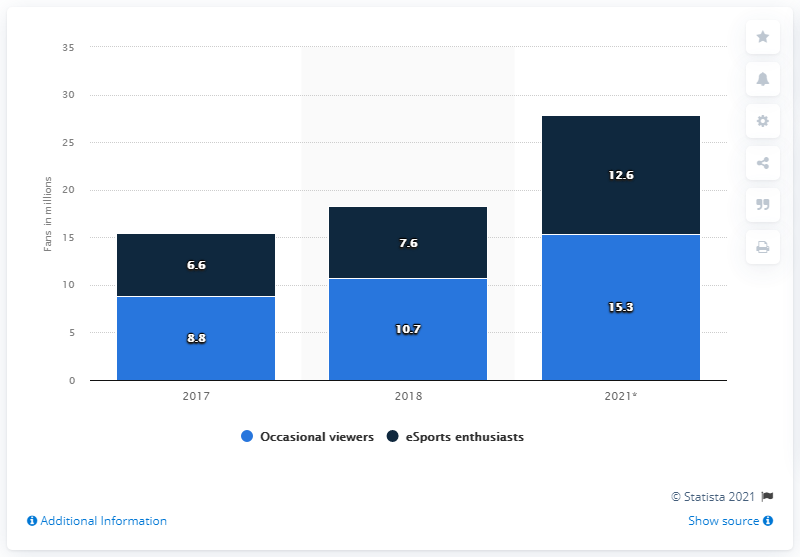Identify some key points in this picture. According to estimates, there were approximately 12.6 million eSports enthusiasts in Brazil in 2021. 